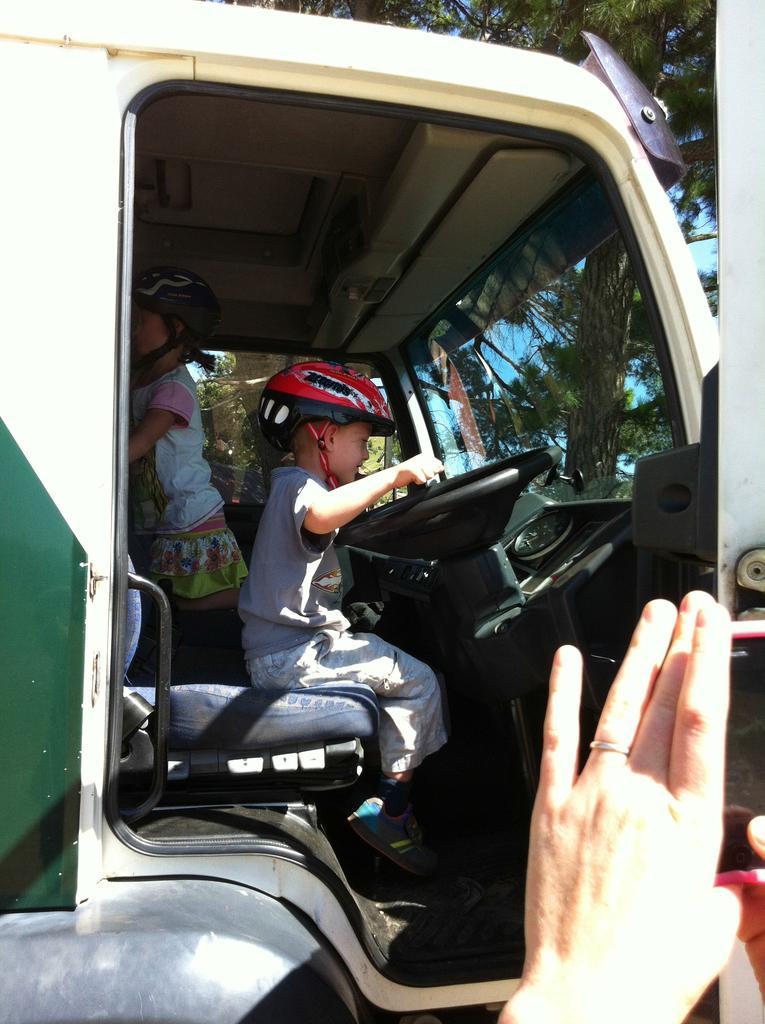Describe this image in one or two sentences. In this image we can see a child sitting in the vehicle and holding a steering in his hands. We can see a person hand holding mobile phone. In the background we can see a child standing and trees through glass. 